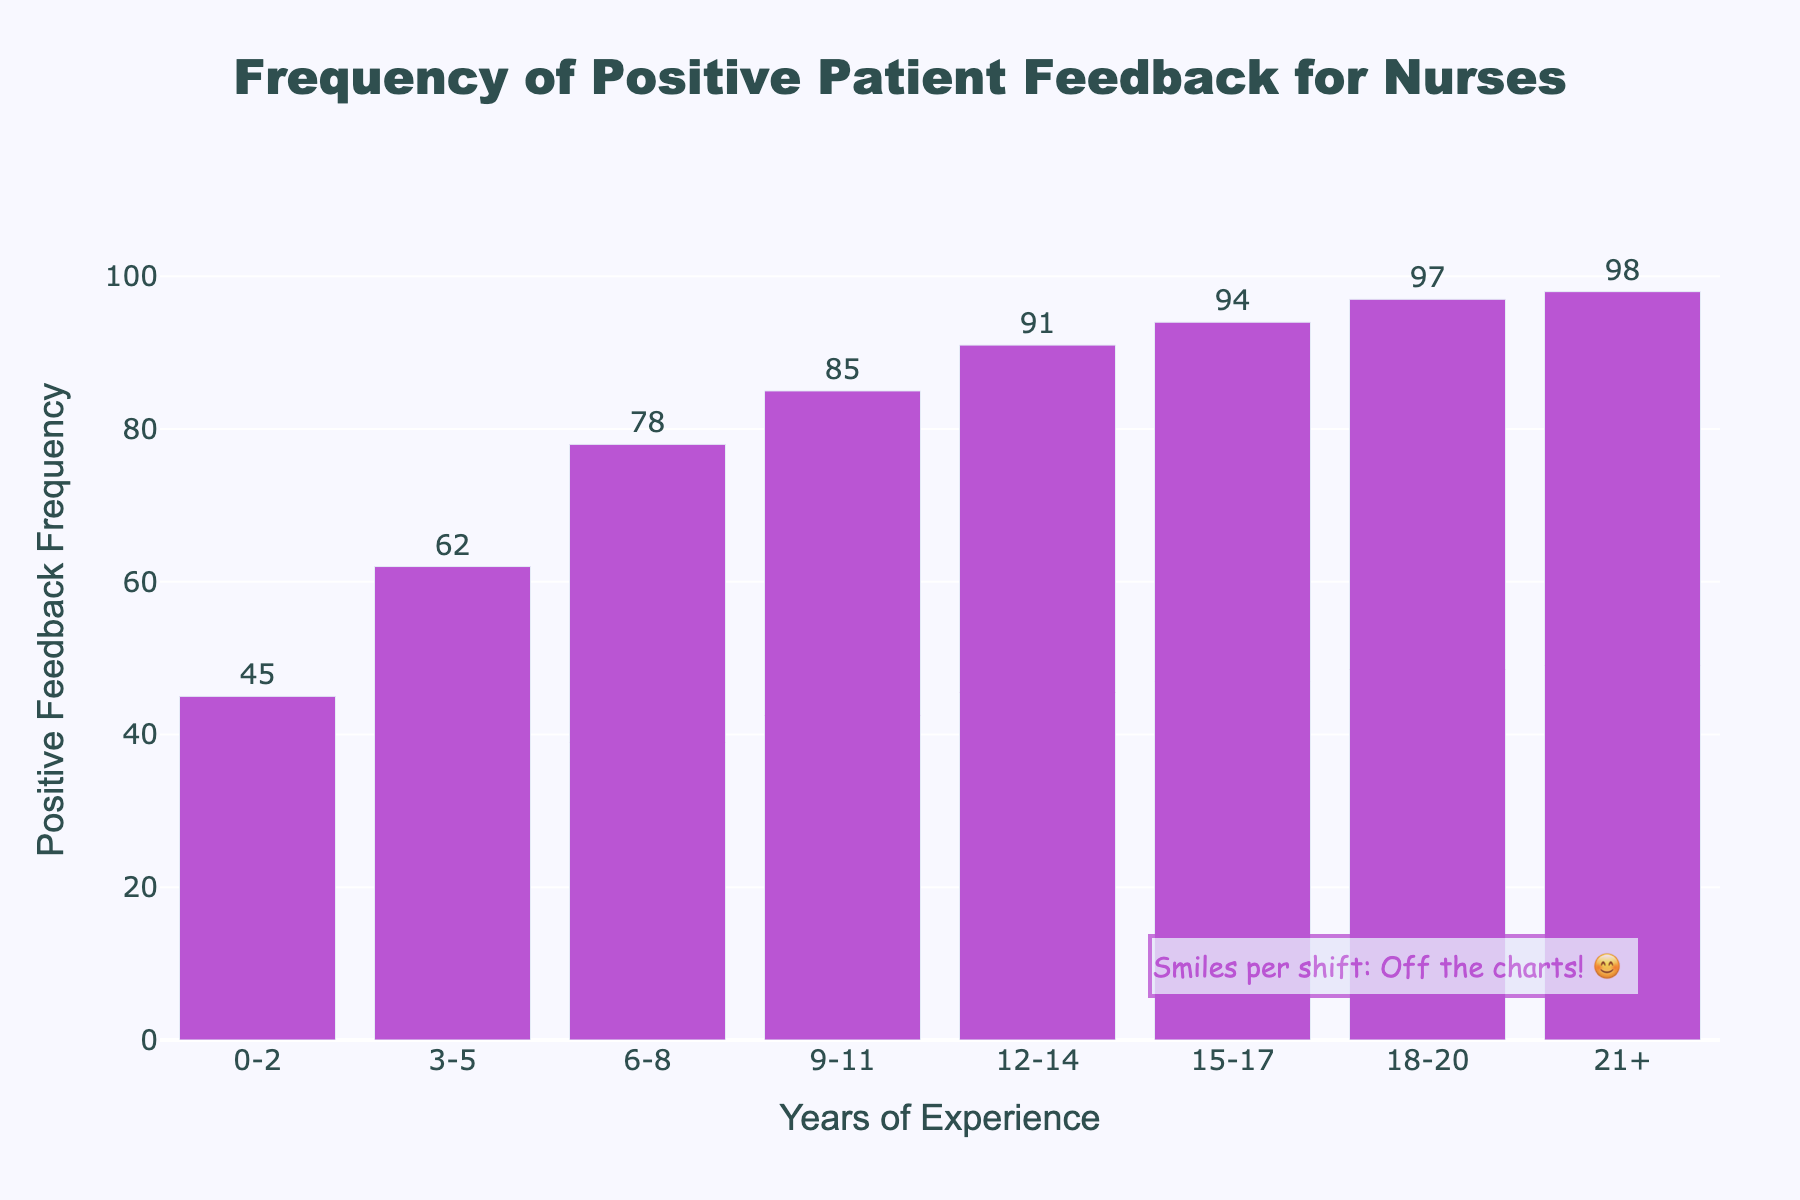What's the title of the figure? The title is located at the top center of the figure and is written in large, darkslategray, Arial Black font.
Answer: Frequency of Positive Patient Feedback for Nurses What's the range of the y-axis? The y-axis ranges from 0 to 110, as indicated by the y-axis ticks and the range specified on the y-axis.
Answer: 0 to 110 Which years of experience group received the highest positive feedback frequency? The group with 21+ years of experience has the highest bar, meaning they received the highest amount of positive feedback which is 98.
Answer: 21+ years How many years of experience does the group with the lowest positive feedback frequency have? The group with 0-2 years of experience has the smallest bar indicating they received the lowest positive feedback frequency, which is 45.
Answer: 0-2 years What's the difference between the positive feedback frequency of nurses with 9-11 years of experience and those with 6-8 years of experience? For 9-11 years of experience, the bar height corresponds to a frequency of 85, and for 6-8 years, it is 78. The difference is calculated as 85 - 78.
Answer: 7 Which experience group received just below 100 positive feedbacks? The 18-20 years experience group has a bar showing 97 positive feedback, which is just below 100.
Answer: 18-20 years Can you list the bars in ascending order of their positive feedback frequencies? Observing the figure, you can order the bars by their heights from shortest to tallest as 0-2, 3-5, 6-8, 9-11, 12-14, 15-17, 18-20, 21+.
Answer: 0-2, 3-5, 6-8, 9-11, 12-14, 15-17, 18-20, 21+ What's the total positive feedback frequency for nurses with 15+ years of experience? Summing up the frequencies for 15-17 years (94), 18-20 years (97), and 21+ years (98), we get 94 + 97 + 98.
Answer: 289 